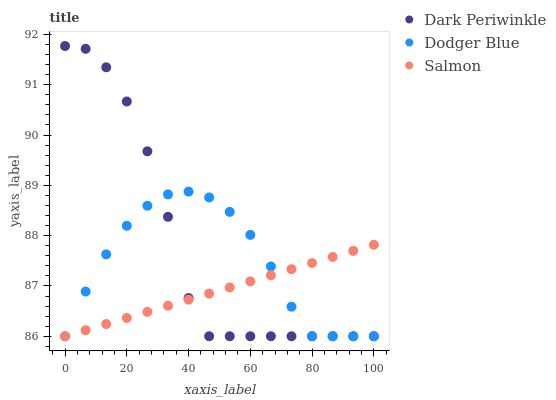Does Salmon have the minimum area under the curve?
Answer yes or no. Yes. Does Dark Periwinkle have the maximum area under the curve?
Answer yes or no. Yes. Does Dodger Blue have the minimum area under the curve?
Answer yes or no. No. Does Dodger Blue have the maximum area under the curve?
Answer yes or no. No. Is Salmon the smoothest?
Answer yes or no. Yes. Is Dark Periwinkle the roughest?
Answer yes or no. Yes. Is Dodger Blue the smoothest?
Answer yes or no. No. Is Dodger Blue the roughest?
Answer yes or no. No. Does Salmon have the lowest value?
Answer yes or no. Yes. Does Dark Periwinkle have the highest value?
Answer yes or no. Yes. Does Dodger Blue have the highest value?
Answer yes or no. No. Does Salmon intersect Dodger Blue?
Answer yes or no. Yes. Is Salmon less than Dodger Blue?
Answer yes or no. No. Is Salmon greater than Dodger Blue?
Answer yes or no. No. 